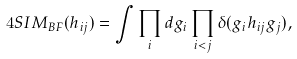Convert formula to latex. <formula><loc_0><loc_0><loc_500><loc_500>4 S I M _ { B F } ( h _ { i j } ) = \int \prod _ { i } d g _ { i } \prod _ { i < j } \delta ( g _ { i } h _ { i j } g _ { j } ) ,</formula> 